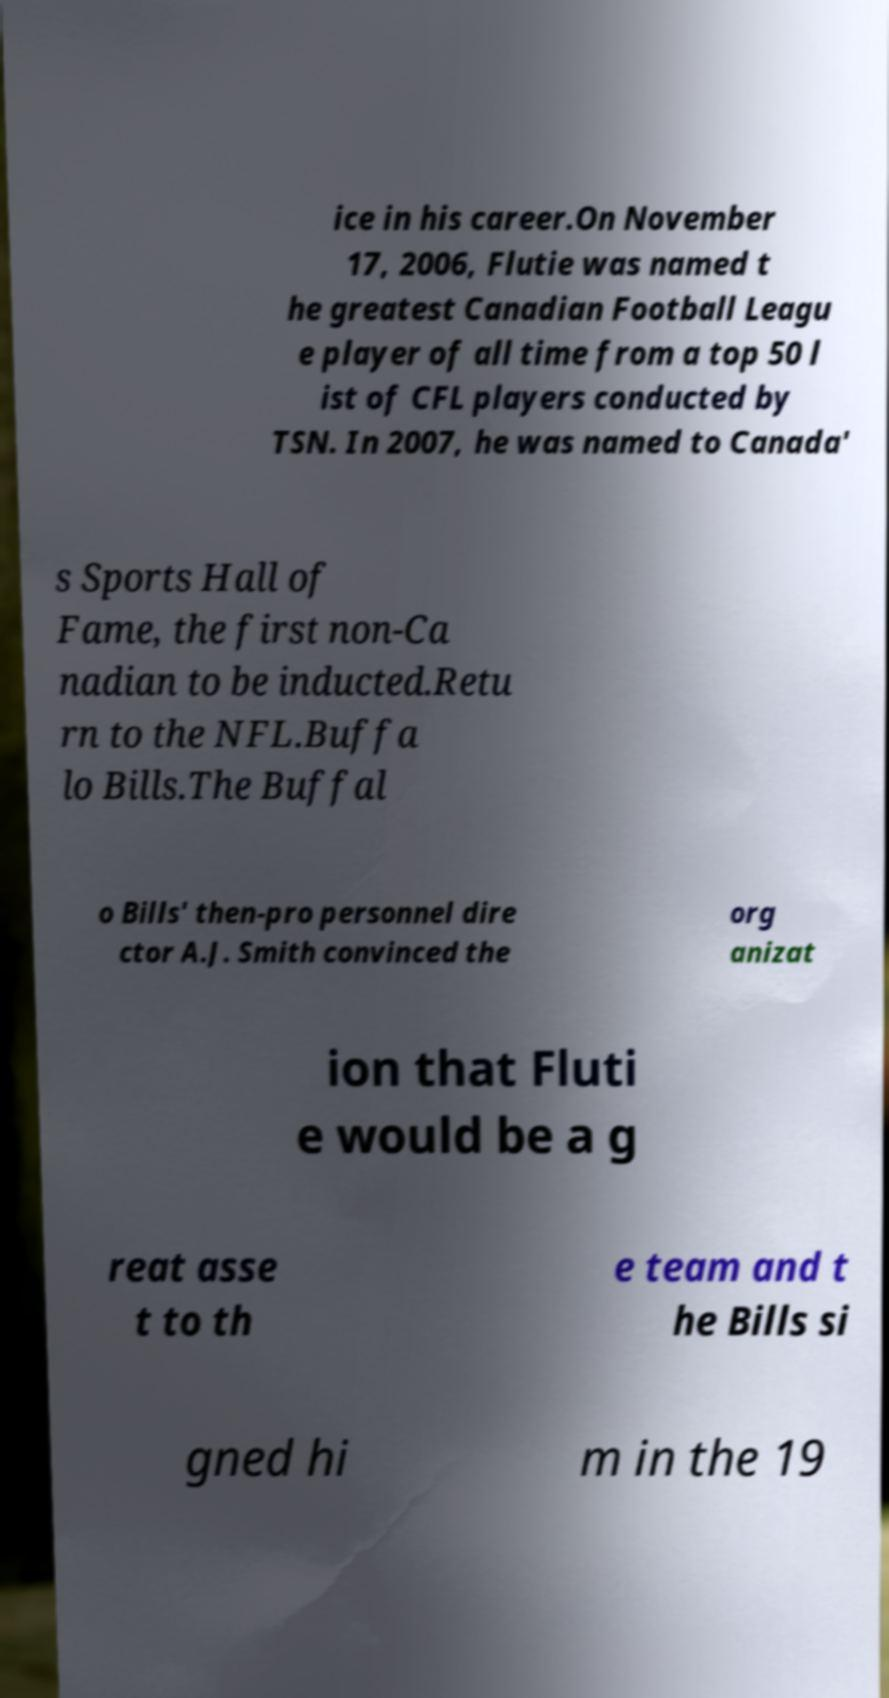Could you extract and type out the text from this image? ice in his career.On November 17, 2006, Flutie was named t he greatest Canadian Football Leagu e player of all time from a top 50 l ist of CFL players conducted by TSN. In 2007, he was named to Canada' s Sports Hall of Fame, the first non-Ca nadian to be inducted.Retu rn to the NFL.Buffa lo Bills.The Buffal o Bills' then-pro personnel dire ctor A.J. Smith convinced the org anizat ion that Fluti e would be a g reat asse t to th e team and t he Bills si gned hi m in the 19 